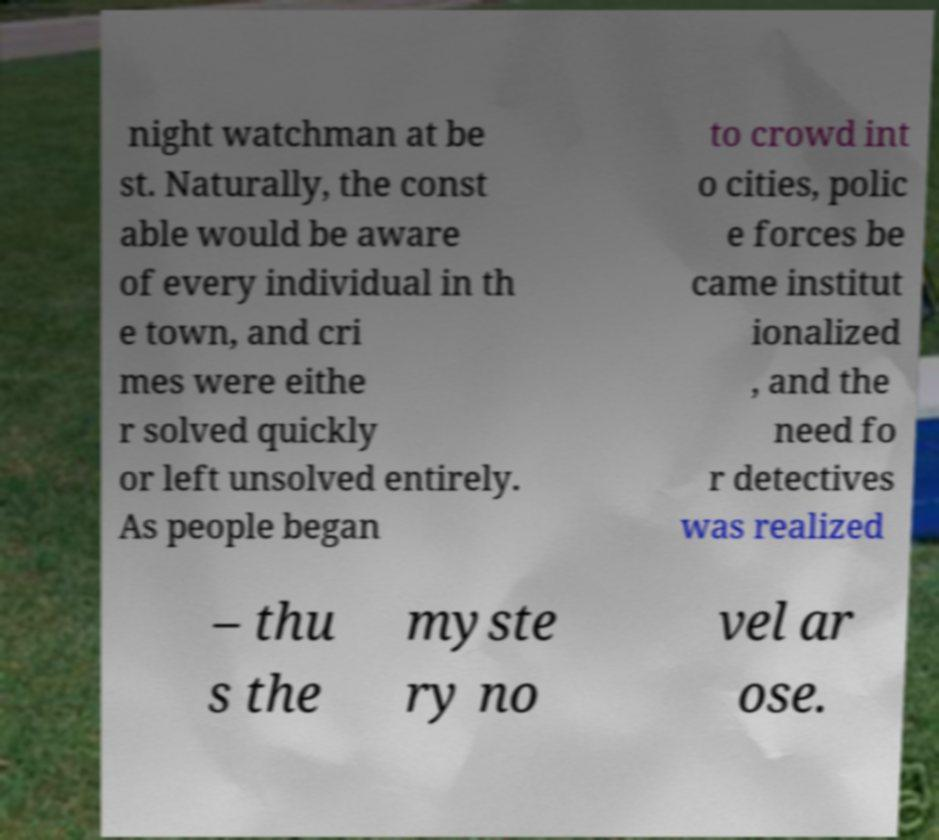What messages or text are displayed in this image? I need them in a readable, typed format. night watchman at be st. Naturally, the const able would be aware of every individual in th e town, and cri mes were eithe r solved quickly or left unsolved entirely. As people began to crowd int o cities, polic e forces be came institut ionalized , and the need fo r detectives was realized – thu s the myste ry no vel ar ose. 